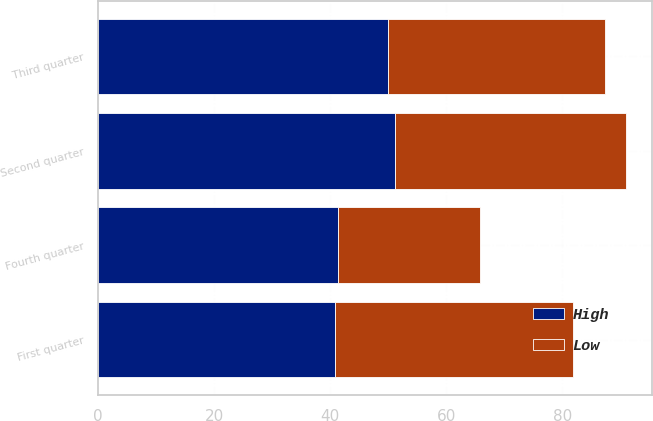Convert chart. <chart><loc_0><loc_0><loc_500><loc_500><stacked_bar_chart><ecel><fcel>First quarter<fcel>Second quarter<fcel>Third quarter<fcel>Fourth quarter<nl><fcel>High<fcel>40.88<fcel>51.11<fcel>50.03<fcel>41.26<nl><fcel>Low<fcel>40.88<fcel>39.77<fcel>37.27<fcel>24.56<nl></chart> 